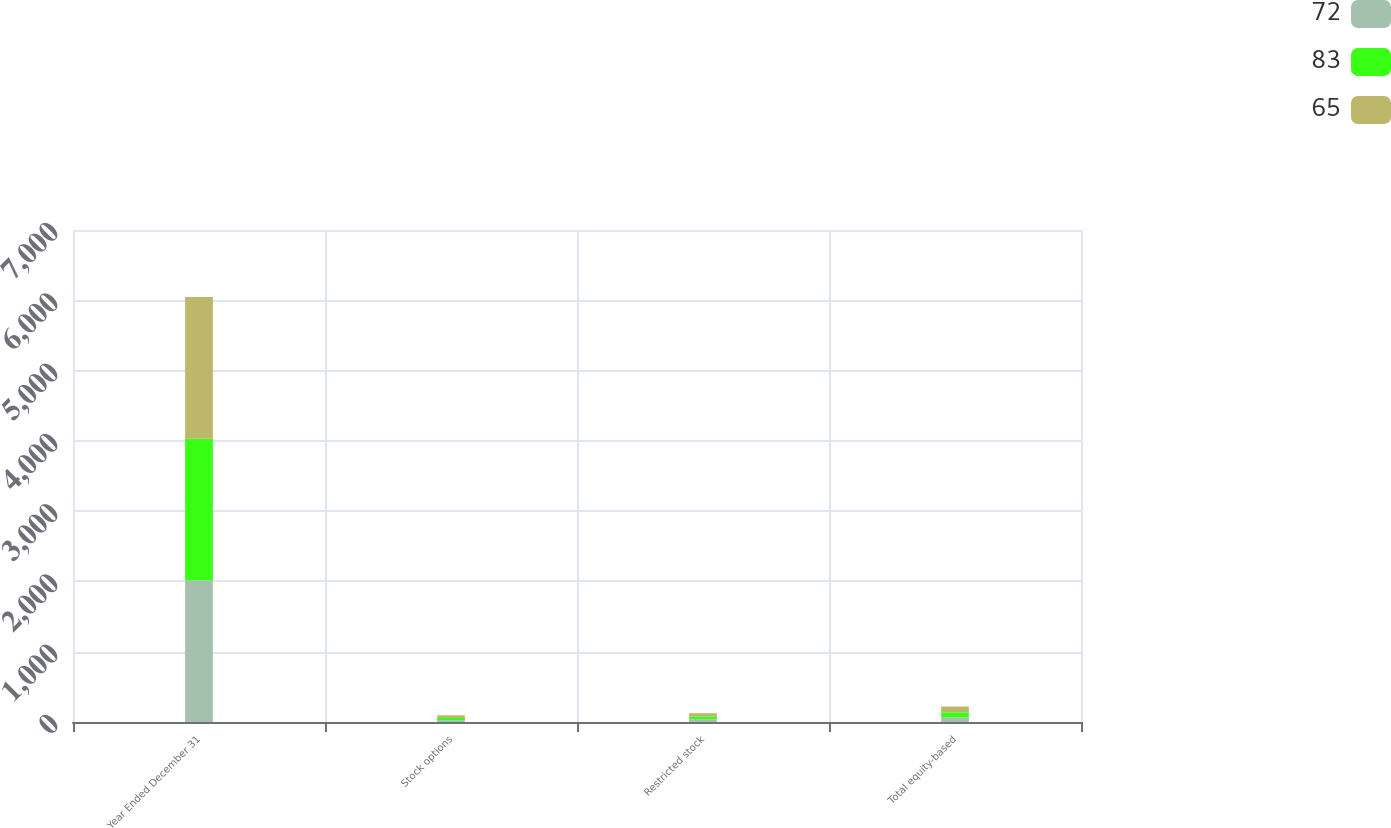<chart> <loc_0><loc_0><loc_500><loc_500><stacked_bar_chart><ecel><fcel>Year Ended December 31<fcel>Stock options<fcel>Restricted stock<fcel>Total equity-based<nl><fcel>72<fcel>2016<fcel>25<fcel>40<fcel>65<nl><fcel>83<fcel>2015<fcel>32<fcel>40<fcel>72<nl><fcel>65<fcel>2014<fcel>38<fcel>45<fcel>83<nl></chart> 